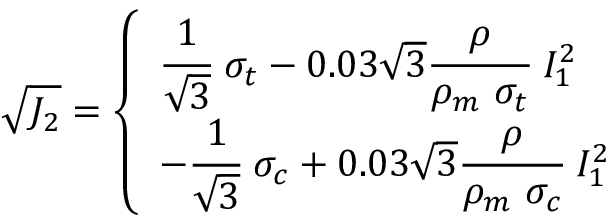Convert formula to latex. <formula><loc_0><loc_0><loc_500><loc_500>{ \sqrt { J _ { 2 } } } = { \left \{ \begin{array} { l l } { { \cfrac { 1 } { \sqrt { 3 } } } \sigma _ { t } - 0 . 0 3 { \sqrt { 3 } } { \cfrac { \rho } { \rho _ { m } \sigma _ { t } } } I _ { 1 } ^ { 2 } } \\ { - { \cfrac { 1 } { \sqrt { 3 } } } \sigma _ { c } + 0 . 0 3 { \sqrt { 3 } } { \cfrac { \rho } { \rho _ { m } \sigma _ { c } } } I _ { 1 } ^ { 2 } } \end{array} }</formula> 